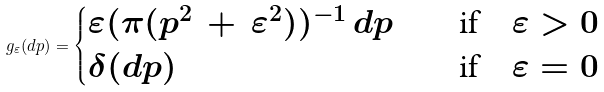<formula> <loc_0><loc_0><loc_500><loc_500>g _ { \varepsilon } ( d p ) = \begin{cases} \varepsilon ( \pi ( p ^ { 2 } \, + \, \varepsilon ^ { 2 } ) ) ^ { - 1 } \, d p \quad & \text {if} \quad \varepsilon > 0 \\ \delta ( d p ) \quad & \text {if} \quad \varepsilon = 0 \\ \end{cases}</formula> 